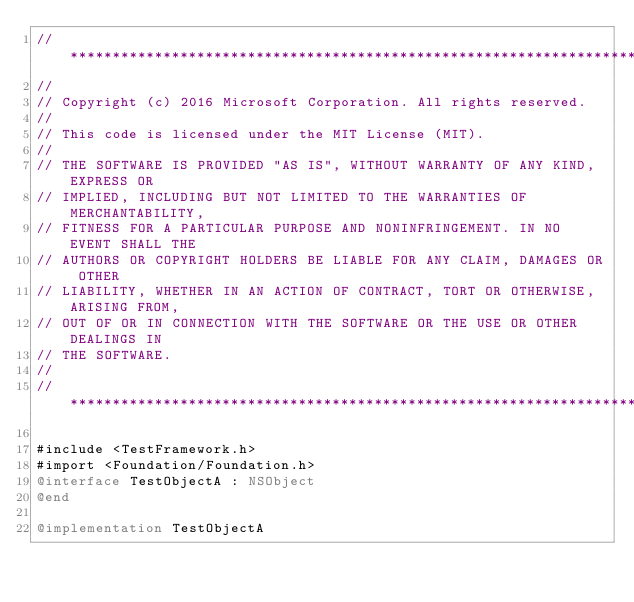Convert code to text. <code><loc_0><loc_0><loc_500><loc_500><_ObjectiveC_>//******************************************************************************
//
// Copyright (c) 2016 Microsoft Corporation. All rights reserved.
//
// This code is licensed under the MIT License (MIT).
//
// THE SOFTWARE IS PROVIDED "AS IS", WITHOUT WARRANTY OF ANY KIND, EXPRESS OR
// IMPLIED, INCLUDING BUT NOT LIMITED TO THE WARRANTIES OF MERCHANTABILITY,
// FITNESS FOR A PARTICULAR PURPOSE AND NONINFRINGEMENT. IN NO EVENT SHALL THE
// AUTHORS OR COPYRIGHT HOLDERS BE LIABLE FOR ANY CLAIM, DAMAGES OR OTHER
// LIABILITY, WHETHER IN AN ACTION OF CONTRACT, TORT OR OTHERWISE, ARISING FROM,
// OUT OF OR IN CONNECTION WITH THE SOFTWARE OR THE USE OR OTHER DEALINGS IN
// THE SOFTWARE.
//
//******************************************************************************

#include <TestFramework.h>
#import <Foundation/Foundation.h>
@interface TestObjectA : NSObject
@end

@implementation TestObjectA</code> 